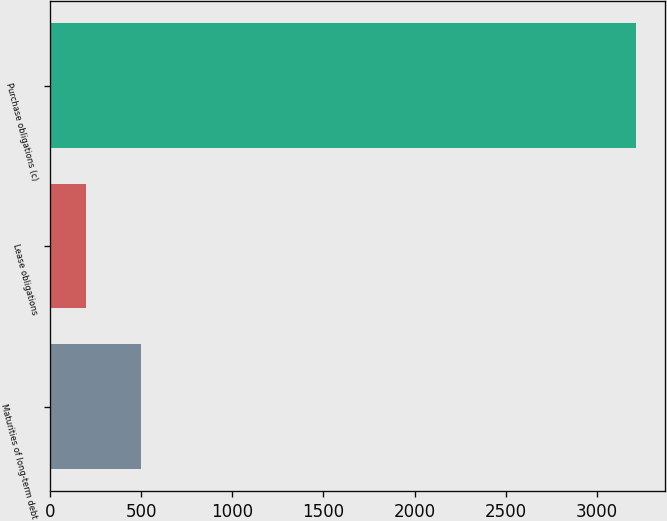Convert chart. <chart><loc_0><loc_0><loc_500><loc_500><bar_chart><fcel>Maturities of long-term debt<fcel>Lease obligations<fcel>Purchase obligations (c)<nl><fcel>499.5<fcel>198<fcel>3213<nl></chart> 